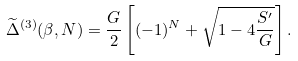<formula> <loc_0><loc_0><loc_500><loc_500>\widetilde { \Delta } ^ { ( 3 ) } ( \beta , N ) = \frac { G } { 2 } \left [ ( - 1 ) ^ { N } + \sqrt { 1 - 4 \frac { S ^ { \prime } } { G } } \right ] .</formula> 